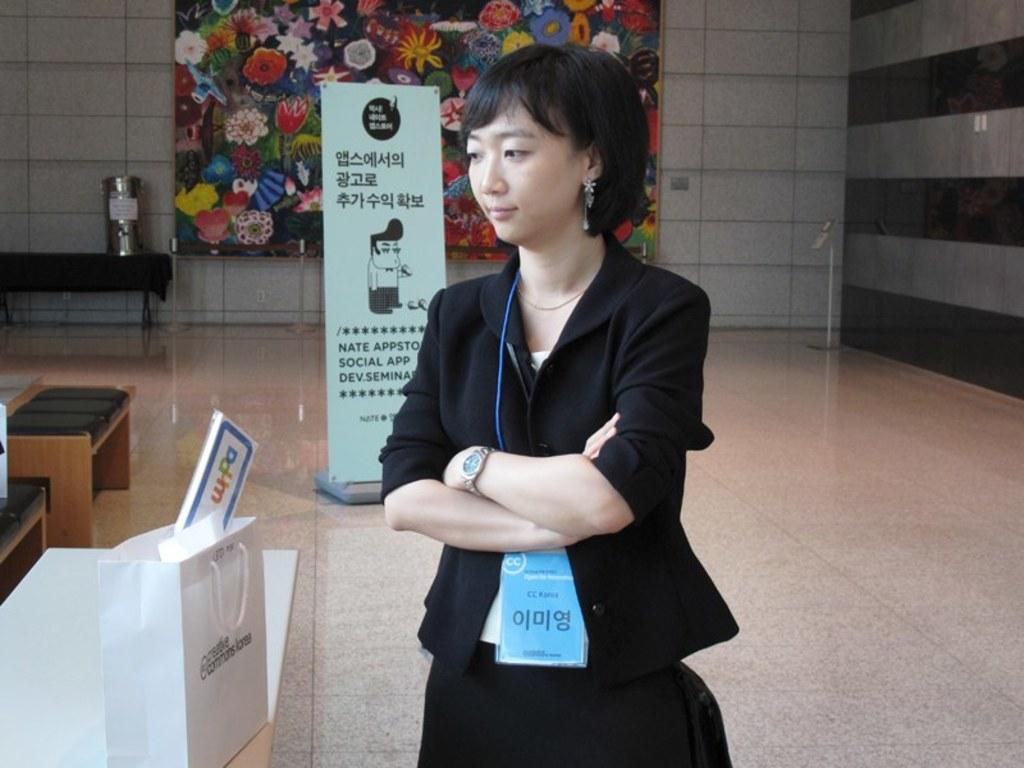What is the main subject of the image? There is a woman standing in the image. What is the woman holding in her hand? The woman is wearing a watch in her hand. What type of identification document is present in the image? There is an identity card in the image. What can be seen in the background of the image? There is a poster in the background of the image. What type of calendar is hanging on the wall in the image? There is no calendar present in the image. How many knees can be seen in the image? There is only one woman in the image, and she has two legs, but we cannot see her knees in the image. 